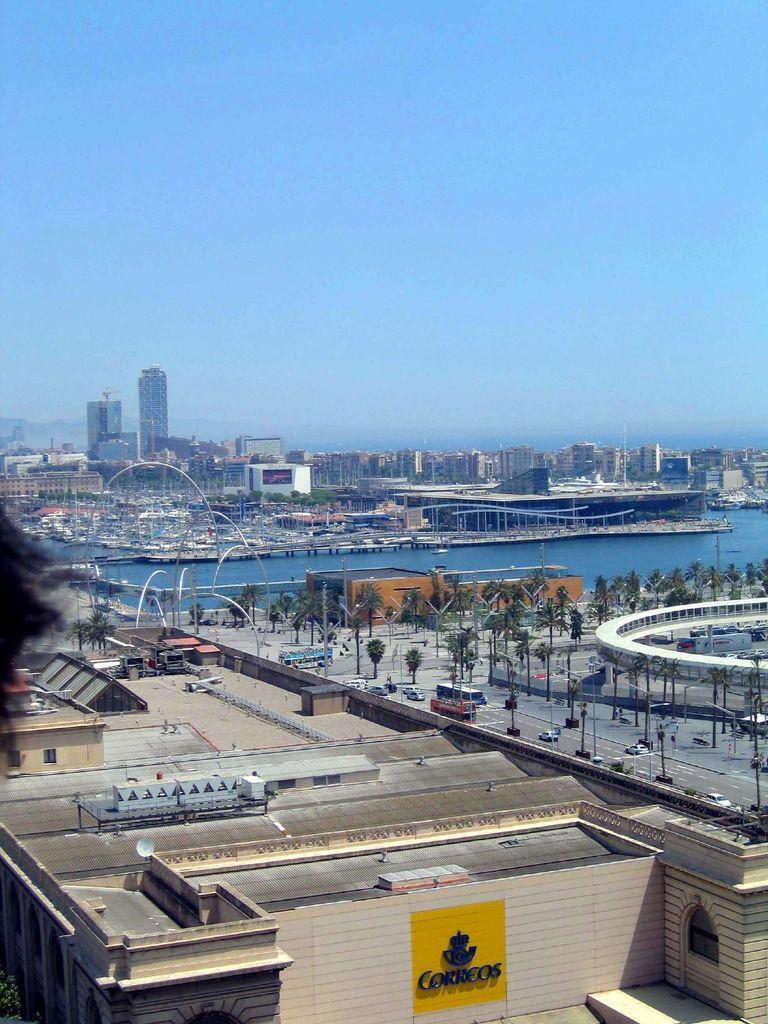In one or two sentences, can you explain what this image depicts? In this image we can see a few buildings, there are some trees, pillars, water and the vehicles on the road, in the background, we can see the sky, also we can see a poster with some text. 